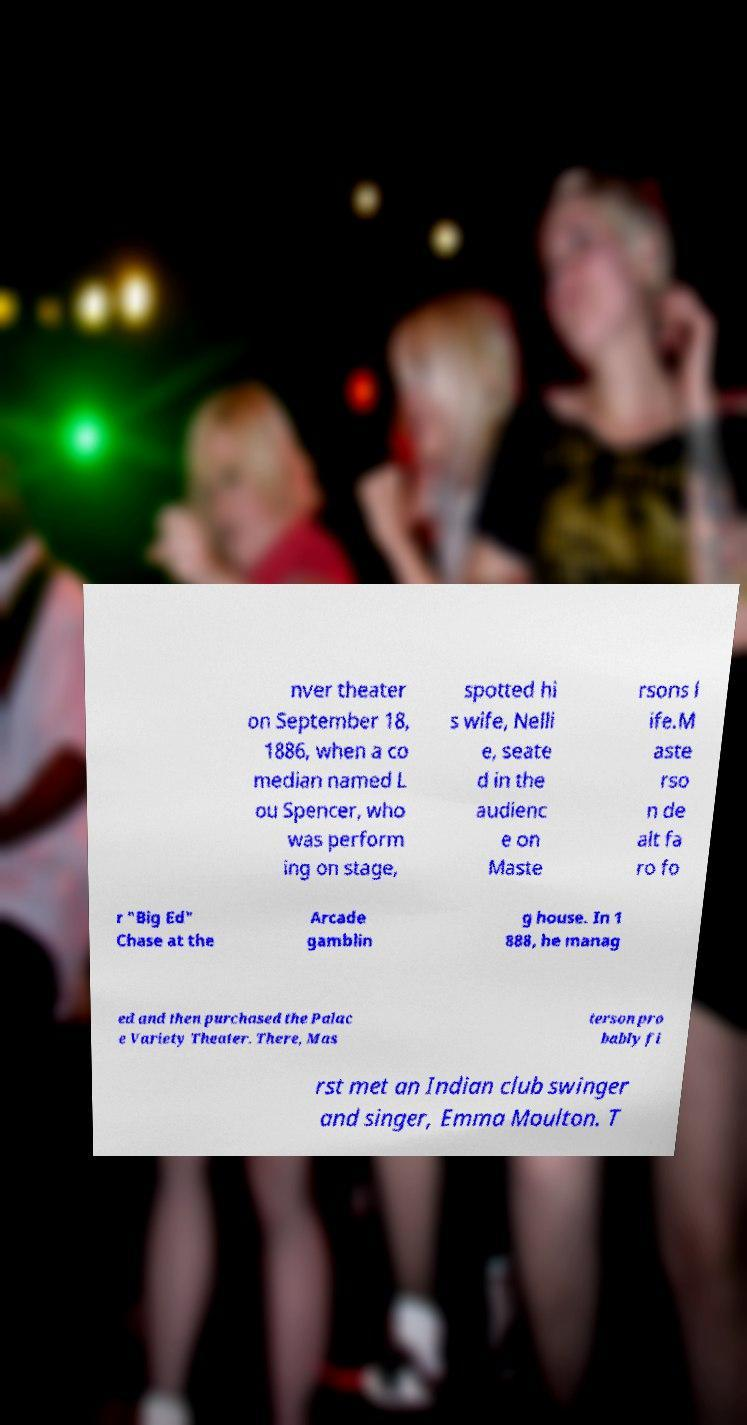Can you accurately transcribe the text from the provided image for me? nver theater on September 18, 1886, when a co median named L ou Spencer, who was perform ing on stage, spotted hi s wife, Nelli e, seate d in the audienc e on Maste rsons l ife.M aste rso n de alt fa ro fo r "Big Ed" Chase at the Arcade gamblin g house. In 1 888, he manag ed and then purchased the Palac e Variety Theater. There, Mas terson pro bably fi rst met an Indian club swinger and singer, Emma Moulton. T 